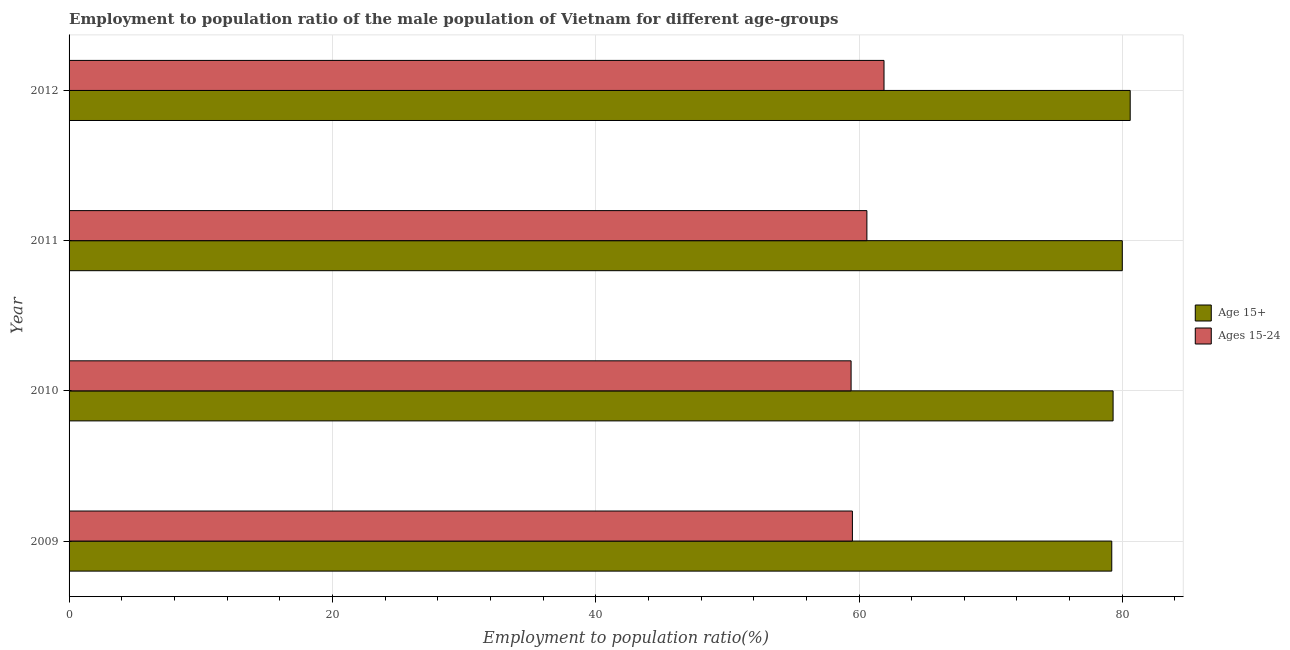How many groups of bars are there?
Your response must be concise. 4. Are the number of bars per tick equal to the number of legend labels?
Your answer should be very brief. Yes. Are the number of bars on each tick of the Y-axis equal?
Ensure brevity in your answer.  Yes. How many bars are there on the 1st tick from the top?
Ensure brevity in your answer.  2. How many bars are there on the 1st tick from the bottom?
Keep it short and to the point. 2. What is the label of the 4th group of bars from the top?
Offer a very short reply. 2009. In how many cases, is the number of bars for a given year not equal to the number of legend labels?
Offer a terse response. 0. What is the employment to population ratio(age 15-24) in 2011?
Your answer should be compact. 60.6. Across all years, what is the maximum employment to population ratio(age 15-24)?
Your answer should be compact. 61.9. Across all years, what is the minimum employment to population ratio(age 15+)?
Provide a succinct answer. 79.2. What is the total employment to population ratio(age 15-24) in the graph?
Offer a terse response. 241.4. What is the difference between the employment to population ratio(age 15-24) in 2011 and that in 2012?
Offer a very short reply. -1.3. What is the difference between the employment to population ratio(age 15+) in 2012 and the employment to population ratio(age 15-24) in 2011?
Your answer should be compact. 20. What is the average employment to population ratio(age 15-24) per year?
Provide a short and direct response. 60.35. In the year 2011, what is the difference between the employment to population ratio(age 15+) and employment to population ratio(age 15-24)?
Offer a terse response. 19.4. In how many years, is the employment to population ratio(age 15-24) greater than 20 %?
Keep it short and to the point. 4. What is the difference between the highest and the second highest employment to population ratio(age 15+)?
Your response must be concise. 0.6. Is the sum of the employment to population ratio(age 15-24) in 2009 and 2012 greater than the maximum employment to population ratio(age 15+) across all years?
Your answer should be compact. Yes. What does the 2nd bar from the top in 2012 represents?
Give a very brief answer. Age 15+. What does the 1st bar from the bottom in 2010 represents?
Your answer should be compact. Age 15+. How many bars are there?
Give a very brief answer. 8. Are all the bars in the graph horizontal?
Provide a succinct answer. Yes. How many years are there in the graph?
Your response must be concise. 4. Does the graph contain any zero values?
Make the answer very short. No. What is the title of the graph?
Offer a terse response. Employment to population ratio of the male population of Vietnam for different age-groups. Does "Quasi money growth" appear as one of the legend labels in the graph?
Make the answer very short. No. What is the label or title of the X-axis?
Your answer should be very brief. Employment to population ratio(%). What is the label or title of the Y-axis?
Give a very brief answer. Year. What is the Employment to population ratio(%) in Age 15+ in 2009?
Provide a short and direct response. 79.2. What is the Employment to population ratio(%) of Ages 15-24 in 2009?
Provide a succinct answer. 59.5. What is the Employment to population ratio(%) in Age 15+ in 2010?
Offer a very short reply. 79.3. What is the Employment to population ratio(%) of Ages 15-24 in 2010?
Offer a very short reply. 59.4. What is the Employment to population ratio(%) in Age 15+ in 2011?
Offer a very short reply. 80. What is the Employment to population ratio(%) of Ages 15-24 in 2011?
Offer a very short reply. 60.6. What is the Employment to population ratio(%) in Age 15+ in 2012?
Your answer should be very brief. 80.6. What is the Employment to population ratio(%) of Ages 15-24 in 2012?
Your answer should be very brief. 61.9. Across all years, what is the maximum Employment to population ratio(%) in Age 15+?
Your answer should be very brief. 80.6. Across all years, what is the maximum Employment to population ratio(%) of Ages 15-24?
Give a very brief answer. 61.9. Across all years, what is the minimum Employment to population ratio(%) of Age 15+?
Your response must be concise. 79.2. Across all years, what is the minimum Employment to population ratio(%) of Ages 15-24?
Offer a terse response. 59.4. What is the total Employment to population ratio(%) in Age 15+ in the graph?
Provide a short and direct response. 319.1. What is the total Employment to population ratio(%) of Ages 15-24 in the graph?
Offer a terse response. 241.4. What is the difference between the Employment to population ratio(%) of Age 15+ in 2009 and that in 2011?
Provide a short and direct response. -0.8. What is the difference between the Employment to population ratio(%) of Ages 15-24 in 2010 and that in 2011?
Make the answer very short. -1.2. What is the difference between the Employment to population ratio(%) of Ages 15-24 in 2011 and that in 2012?
Your answer should be very brief. -1.3. What is the difference between the Employment to population ratio(%) of Age 15+ in 2009 and the Employment to population ratio(%) of Ages 15-24 in 2010?
Your answer should be very brief. 19.8. What is the difference between the Employment to population ratio(%) of Age 15+ in 2009 and the Employment to population ratio(%) of Ages 15-24 in 2012?
Ensure brevity in your answer.  17.3. What is the difference between the Employment to population ratio(%) of Age 15+ in 2010 and the Employment to population ratio(%) of Ages 15-24 in 2011?
Ensure brevity in your answer.  18.7. What is the difference between the Employment to population ratio(%) in Age 15+ in 2010 and the Employment to population ratio(%) in Ages 15-24 in 2012?
Your answer should be very brief. 17.4. What is the difference between the Employment to population ratio(%) in Age 15+ in 2011 and the Employment to population ratio(%) in Ages 15-24 in 2012?
Offer a very short reply. 18.1. What is the average Employment to population ratio(%) of Age 15+ per year?
Your response must be concise. 79.78. What is the average Employment to population ratio(%) of Ages 15-24 per year?
Offer a terse response. 60.35. In the year 2009, what is the difference between the Employment to population ratio(%) in Age 15+ and Employment to population ratio(%) in Ages 15-24?
Your answer should be very brief. 19.7. In the year 2011, what is the difference between the Employment to population ratio(%) of Age 15+ and Employment to population ratio(%) of Ages 15-24?
Make the answer very short. 19.4. What is the ratio of the Employment to population ratio(%) in Age 15+ in 2009 to that in 2010?
Offer a terse response. 1. What is the ratio of the Employment to population ratio(%) of Ages 15-24 in 2009 to that in 2010?
Ensure brevity in your answer.  1. What is the ratio of the Employment to population ratio(%) of Age 15+ in 2009 to that in 2011?
Provide a succinct answer. 0.99. What is the ratio of the Employment to population ratio(%) in Ages 15-24 in 2009 to that in 2011?
Ensure brevity in your answer.  0.98. What is the ratio of the Employment to population ratio(%) in Age 15+ in 2009 to that in 2012?
Provide a short and direct response. 0.98. What is the ratio of the Employment to population ratio(%) of Ages 15-24 in 2009 to that in 2012?
Ensure brevity in your answer.  0.96. What is the ratio of the Employment to population ratio(%) of Ages 15-24 in 2010 to that in 2011?
Keep it short and to the point. 0.98. What is the ratio of the Employment to population ratio(%) of Age 15+ in 2010 to that in 2012?
Your answer should be compact. 0.98. What is the ratio of the Employment to population ratio(%) of Ages 15-24 in 2010 to that in 2012?
Make the answer very short. 0.96. What is the ratio of the Employment to population ratio(%) of Ages 15-24 in 2011 to that in 2012?
Your answer should be very brief. 0.98. What is the difference between the highest and the lowest Employment to population ratio(%) in Age 15+?
Keep it short and to the point. 1.4. What is the difference between the highest and the lowest Employment to population ratio(%) of Ages 15-24?
Your answer should be very brief. 2.5. 